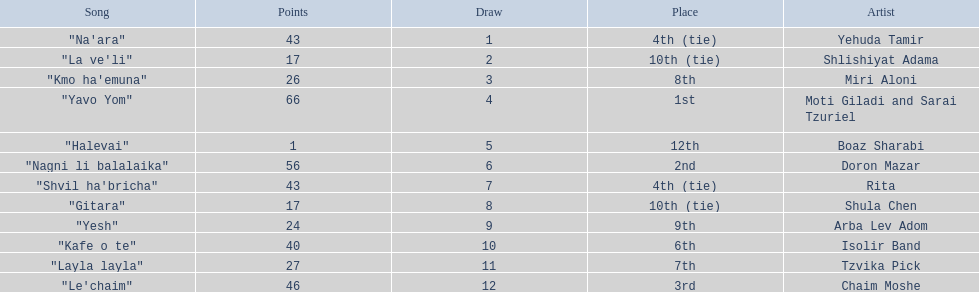How many artists are there? Yehuda Tamir, Shlishiyat Adama, Miri Aloni, Moti Giladi and Sarai Tzuriel, Boaz Sharabi, Doron Mazar, Rita, Shula Chen, Arba Lev Adom, Isolir Band, Tzvika Pick, Chaim Moshe. What is the least amount of points awarded? 1. Who was the artist awarded those points? Boaz Sharabi. 